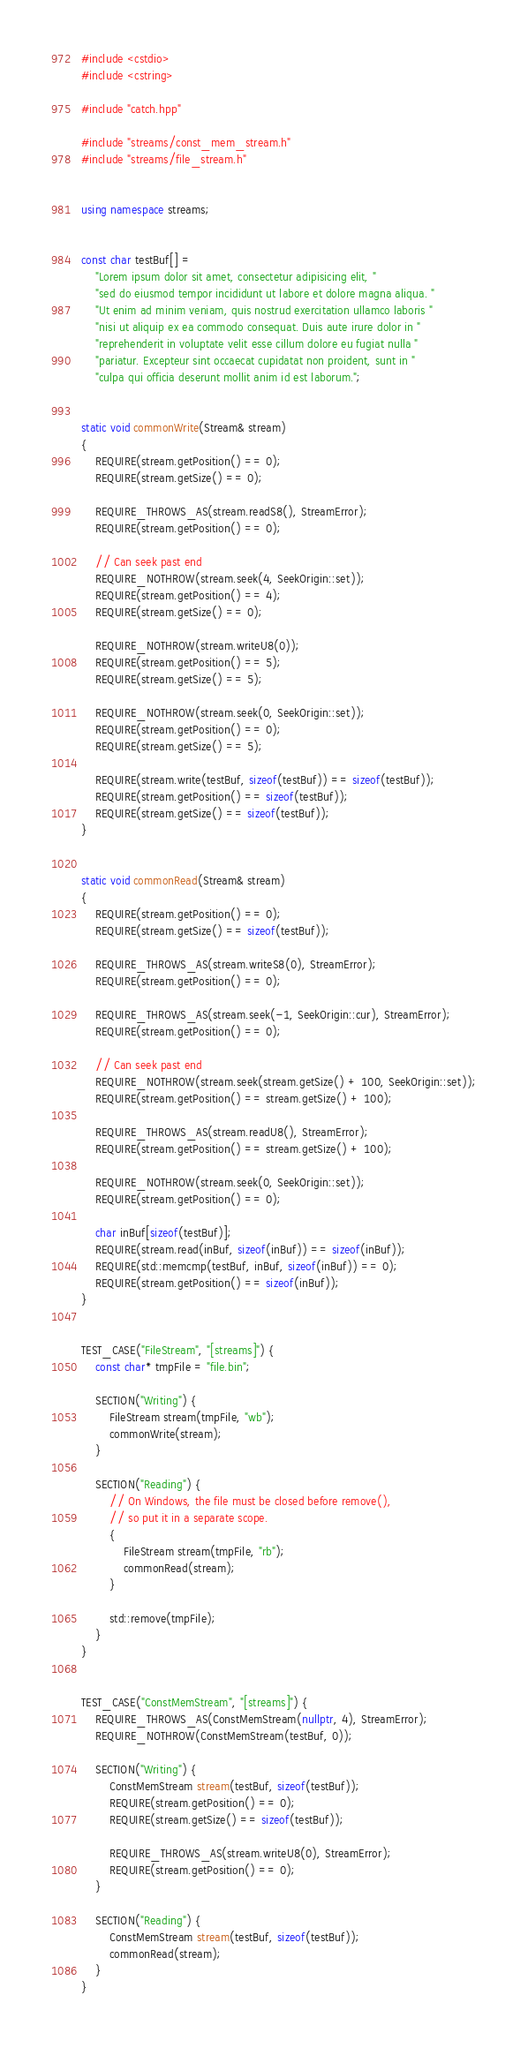<code> <loc_0><loc_0><loc_500><loc_500><_C++_>
#include <cstdio>
#include <cstring>

#include "catch.hpp"

#include "streams/const_mem_stream.h"
#include "streams/file_stream.h"


using namespace streams;


const char testBuf[] =
    "Lorem ipsum dolor sit amet, consectetur adipisicing elit, "
    "sed do eiusmod tempor incididunt ut labore et dolore magna aliqua. "
    "Ut enim ad minim veniam, quis nostrud exercitation ullamco laboris "
    "nisi ut aliquip ex ea commodo consequat. Duis aute irure dolor in "
    "reprehenderit in voluptate velit esse cillum dolore eu fugiat nulla "
    "pariatur. Excepteur sint occaecat cupidatat non proident, sunt in "
    "culpa qui officia deserunt mollit anim id est laborum.";


static void commonWrite(Stream& stream)
{
    REQUIRE(stream.getPosition() == 0);
    REQUIRE(stream.getSize() == 0);

    REQUIRE_THROWS_AS(stream.readS8(), StreamError);
    REQUIRE(stream.getPosition() == 0);

    // Can seek past end
    REQUIRE_NOTHROW(stream.seek(4, SeekOrigin::set));
    REQUIRE(stream.getPosition() == 4);
    REQUIRE(stream.getSize() == 0);

    REQUIRE_NOTHROW(stream.writeU8(0));
    REQUIRE(stream.getPosition() == 5);
    REQUIRE(stream.getSize() == 5);

    REQUIRE_NOTHROW(stream.seek(0, SeekOrigin::set));
    REQUIRE(stream.getPosition() == 0);
    REQUIRE(stream.getSize() == 5);

    REQUIRE(stream.write(testBuf, sizeof(testBuf)) == sizeof(testBuf));
    REQUIRE(stream.getPosition() == sizeof(testBuf));
    REQUIRE(stream.getSize() == sizeof(testBuf));
}


static void commonRead(Stream& stream)
{
    REQUIRE(stream.getPosition() == 0);
    REQUIRE(stream.getSize() == sizeof(testBuf));

    REQUIRE_THROWS_AS(stream.writeS8(0), StreamError);
    REQUIRE(stream.getPosition() == 0);

    REQUIRE_THROWS_AS(stream.seek(-1, SeekOrigin::cur), StreamError);
    REQUIRE(stream.getPosition() == 0);

    // Can seek past end
    REQUIRE_NOTHROW(stream.seek(stream.getSize() + 100, SeekOrigin::set));
    REQUIRE(stream.getPosition() == stream.getSize() + 100);

    REQUIRE_THROWS_AS(stream.readU8(), StreamError);
    REQUIRE(stream.getPosition() == stream.getSize() + 100);

    REQUIRE_NOTHROW(stream.seek(0, SeekOrigin::set));
    REQUIRE(stream.getPosition() == 0);

    char inBuf[sizeof(testBuf)];
    REQUIRE(stream.read(inBuf, sizeof(inBuf)) == sizeof(inBuf));
    REQUIRE(std::memcmp(testBuf, inBuf, sizeof(inBuf)) == 0);
    REQUIRE(stream.getPosition() == sizeof(inBuf));
}


TEST_CASE("FileStream", "[streams]") {
    const char* tmpFile = "file.bin";

    SECTION("Writing") {
        FileStream stream(tmpFile, "wb");
        commonWrite(stream);
    }

    SECTION("Reading") {
        // On Windows, the file must be closed before remove(),
        // so put it in a separate scope.
        {
            FileStream stream(tmpFile, "rb");
            commonRead(stream);
        }

        std::remove(tmpFile);
    }
}


TEST_CASE("ConstMemStream", "[streams]") {
    REQUIRE_THROWS_AS(ConstMemStream(nullptr, 4), StreamError);
    REQUIRE_NOTHROW(ConstMemStream(testBuf, 0));

    SECTION("Writing") {
        ConstMemStream stream(testBuf, sizeof(testBuf));
        REQUIRE(stream.getPosition() == 0);
        REQUIRE(stream.getSize() == sizeof(testBuf));

        REQUIRE_THROWS_AS(stream.writeU8(0), StreamError);
        REQUIRE(stream.getPosition() == 0);
    }

    SECTION("Reading") {
        ConstMemStream stream(testBuf, sizeof(testBuf));
        commonRead(stream);
    }
}
</code> 